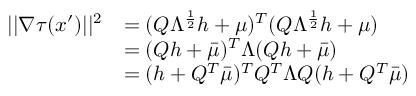Convert formula to latex. <formula><loc_0><loc_0><loc_500><loc_500>\begin{array} { r l } { | | \nabla \tau ( x ^ { \prime } ) | | ^ { 2 } } & { = ( Q \Lambda ^ { \frac { 1 } { 2 } } h + \mu ) ^ { T } ( Q \Lambda ^ { \frac { 1 } { 2 } } h + \mu ) } \\ & { = ( Q h + \bar { \mu } ) ^ { T } \Lambda ( Q h + \bar { \mu } ) } \\ & { = ( h + Q ^ { T } \bar { \mu } ) ^ { T } Q ^ { T } \Lambda Q ( h + Q ^ { T } \bar { \mu } ) } \end{array}</formula> 